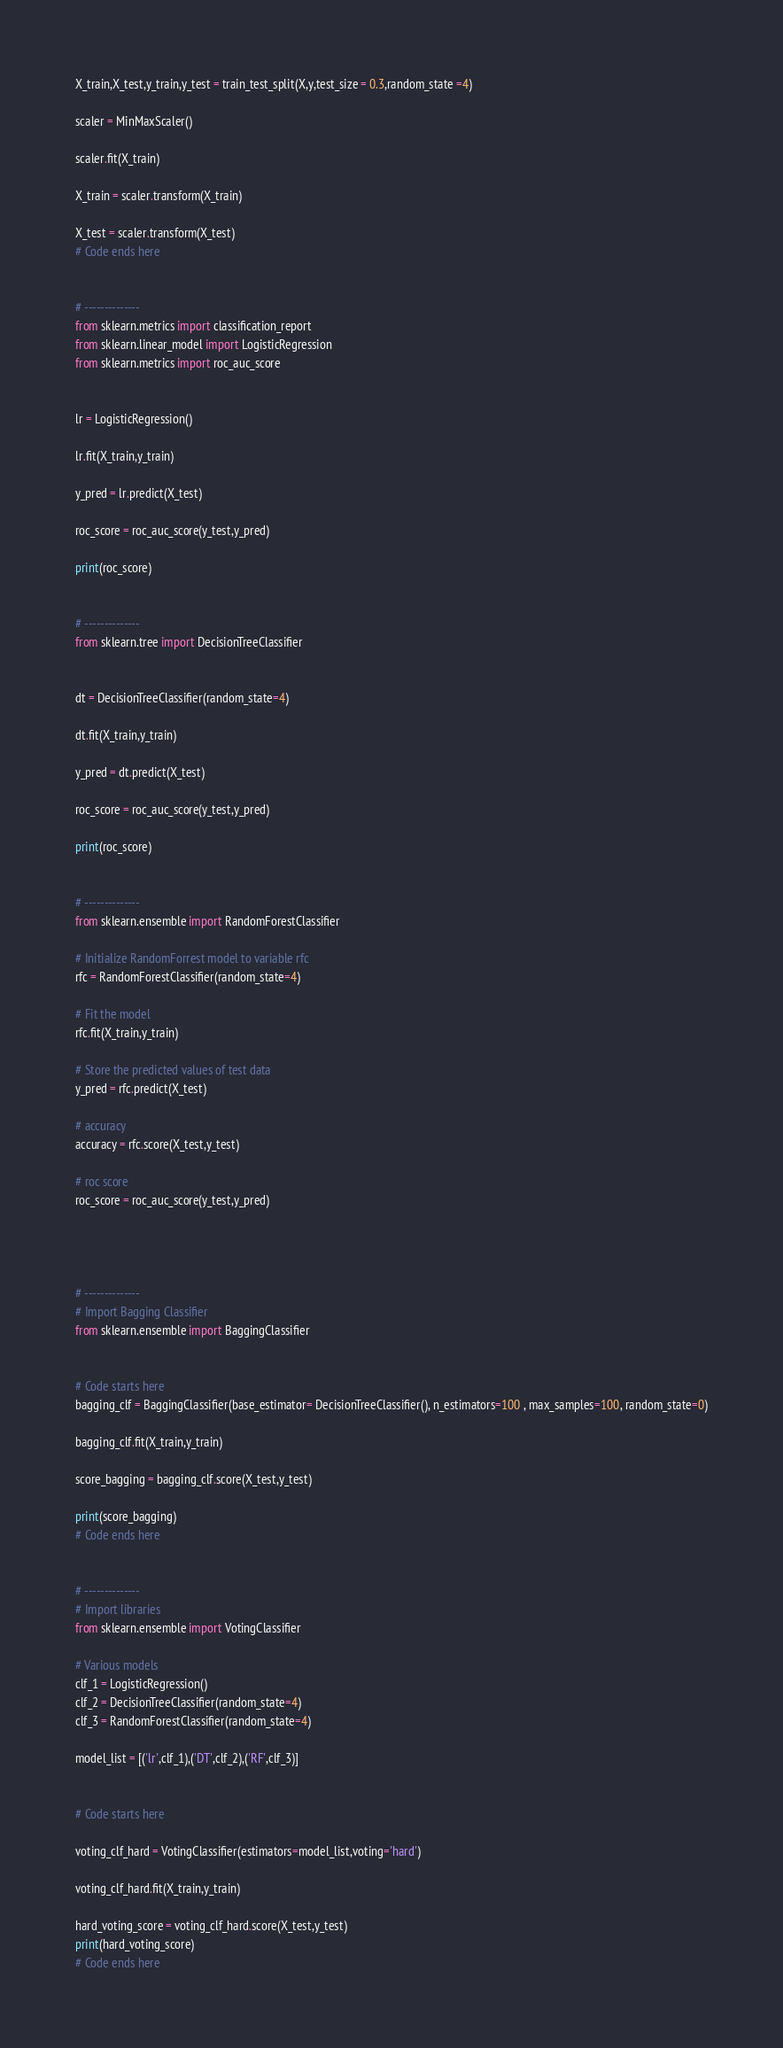Convert code to text. <code><loc_0><loc_0><loc_500><loc_500><_Python_>
X_train,X_test,y_train,y_test = train_test_split(X,y,test_size = 0.3,random_state =4) 

scaler = MinMaxScaler()

scaler.fit(X_train)

X_train = scaler.transform(X_train)

X_test = scaler.transform(X_test)
# Code ends here


# --------------
from sklearn.metrics import classification_report
from sklearn.linear_model import LogisticRegression
from sklearn.metrics import roc_auc_score


lr = LogisticRegression()

lr.fit(X_train,y_train)

y_pred = lr.predict(X_test)

roc_score = roc_auc_score(y_test,y_pred)

print(roc_score)


# --------------
from sklearn.tree import DecisionTreeClassifier


dt = DecisionTreeClassifier(random_state=4)

dt.fit(X_train,y_train)

y_pred = dt.predict(X_test)

roc_score = roc_auc_score(y_test,y_pred)

print(roc_score)


# --------------
from sklearn.ensemble import RandomForestClassifier

# Initialize RandomForrest model to variable rfc
rfc = RandomForestClassifier(random_state=4)

# Fit the model
rfc.fit(X_train,y_train)

# Store the predicted values of test data
y_pred = rfc.predict(X_test)

# accuracy
accuracy = rfc.score(X_test,y_test)

# roc score
roc_score = roc_auc_score(y_test,y_pred)




# --------------
# Import Bagging Classifier
from sklearn.ensemble import BaggingClassifier


# Code starts here
bagging_clf = BaggingClassifier(base_estimator= DecisionTreeClassifier(), n_estimators=100 , max_samples=100, random_state=0)

bagging_clf.fit(X_train,y_train)

score_bagging = bagging_clf.score(X_test,y_test)

print(score_bagging)
# Code ends here


# --------------
# Import libraries
from sklearn.ensemble import VotingClassifier

# Various models
clf_1 = LogisticRegression()
clf_2 = DecisionTreeClassifier(random_state=4)
clf_3 = RandomForestClassifier(random_state=4)

model_list = [('lr',clf_1),('DT',clf_2),('RF',clf_3)]


# Code starts here

voting_clf_hard = VotingClassifier(estimators=model_list,voting='hard')

voting_clf_hard.fit(X_train,y_train)

hard_voting_score = voting_clf_hard.score(X_test,y_test)
print(hard_voting_score)
# Code ends here


</code> 